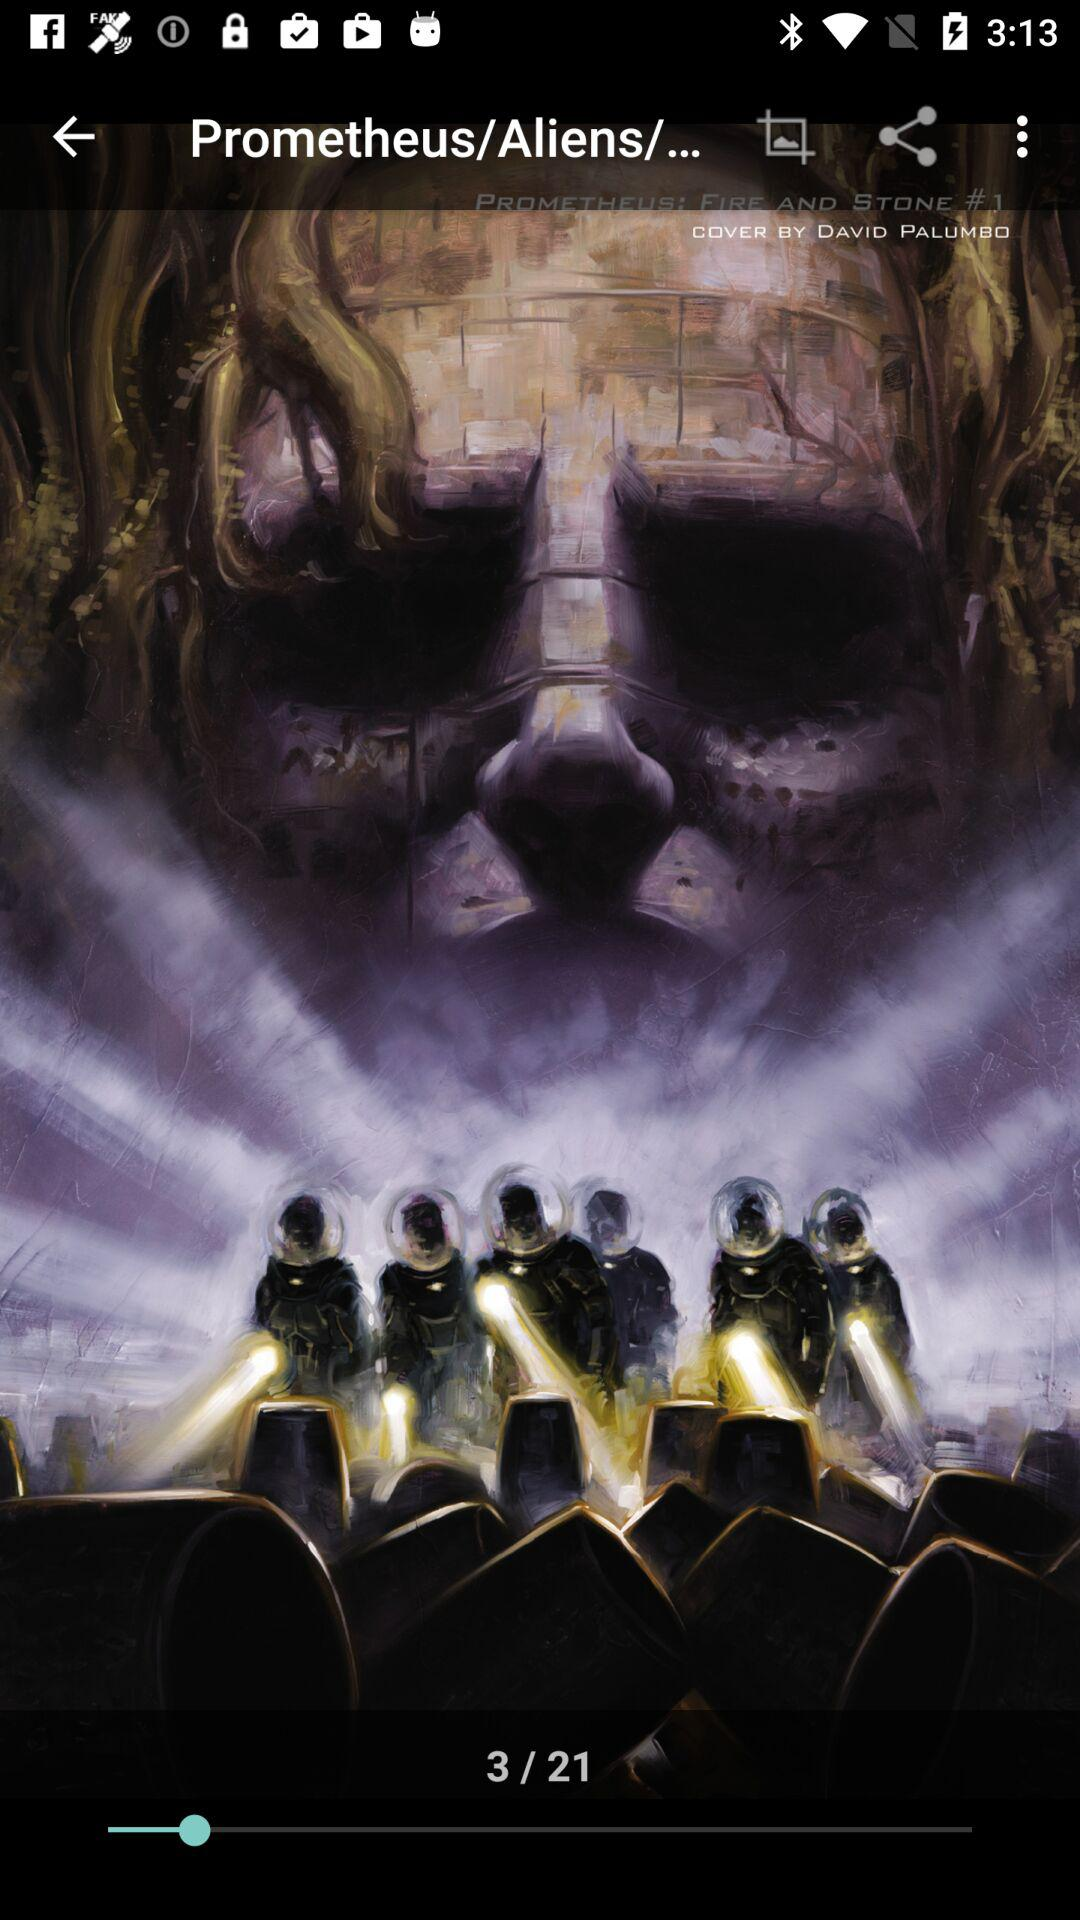Which image am I looking at? You are looking at the third image. 